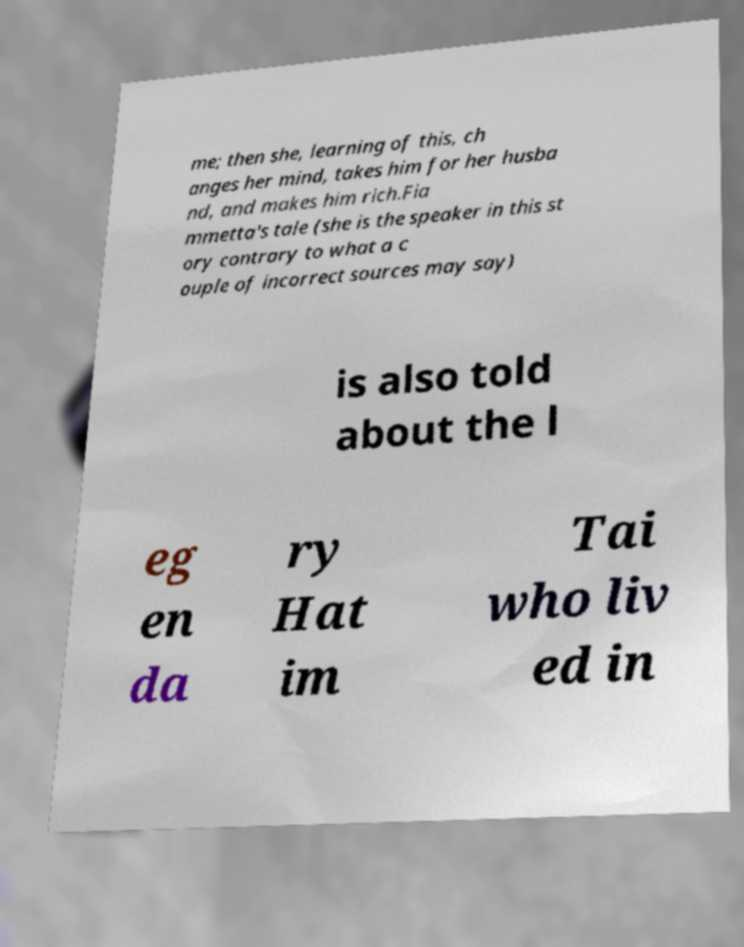Could you assist in decoding the text presented in this image and type it out clearly? me; then she, learning of this, ch anges her mind, takes him for her husba nd, and makes him rich.Fia mmetta's tale (she is the speaker in this st ory contrary to what a c ouple of incorrect sources may say) is also told about the l eg en da ry Hat im Tai who liv ed in 